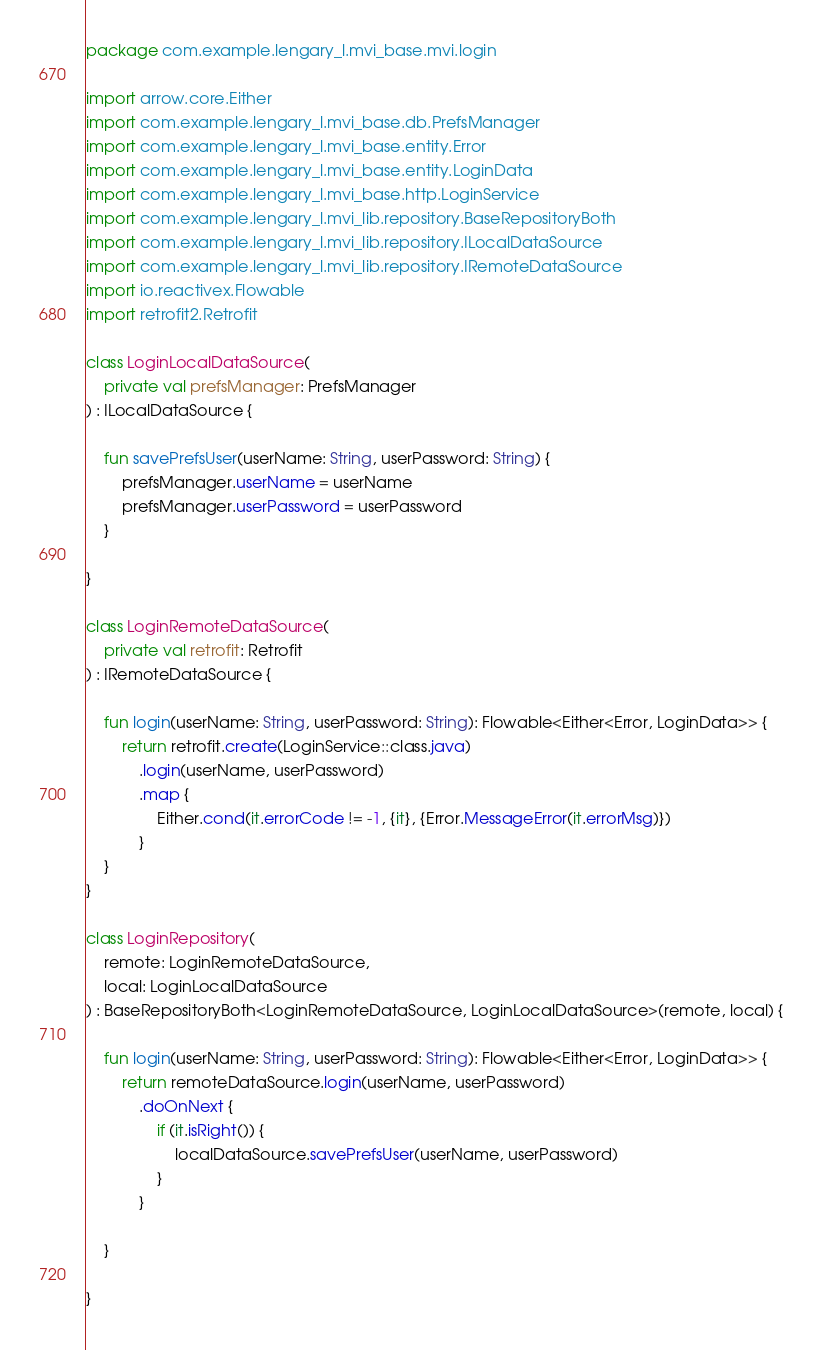Convert code to text. <code><loc_0><loc_0><loc_500><loc_500><_Kotlin_>package com.example.lengary_l.mvi_base.mvi.login

import arrow.core.Either
import com.example.lengary_l.mvi_base.db.PrefsManager
import com.example.lengary_l.mvi_base.entity.Error
import com.example.lengary_l.mvi_base.entity.LoginData
import com.example.lengary_l.mvi_base.http.LoginService
import com.example.lengary_l.mvi_lib.repository.BaseRepositoryBoth
import com.example.lengary_l.mvi_lib.repository.ILocalDataSource
import com.example.lengary_l.mvi_lib.repository.IRemoteDataSource
import io.reactivex.Flowable
import retrofit2.Retrofit

class LoginLocalDataSource(
    private val prefsManager: PrefsManager
) : ILocalDataSource {

    fun savePrefsUser(userName: String, userPassword: String) {
        prefsManager.userName = userName
        prefsManager.userPassword = userPassword
    }

}

class LoginRemoteDataSource(
    private val retrofit: Retrofit
) : IRemoteDataSource {

    fun login(userName: String, userPassword: String): Flowable<Either<Error, LoginData>> {
        return retrofit.create(LoginService::class.java)
            .login(userName, userPassword)
            .map {
                Either.cond(it.errorCode != -1, {it}, {Error.MessageError(it.errorMsg)})
            }
    }
}

class LoginRepository(
    remote: LoginRemoteDataSource,
    local: LoginLocalDataSource
) : BaseRepositoryBoth<LoginRemoteDataSource, LoginLocalDataSource>(remote, local) {

    fun login(userName: String, userPassword: String): Flowable<Either<Error, LoginData>> {
        return remoteDataSource.login(userName, userPassword)
            .doOnNext {
                if (it.isRight()) {
                    localDataSource.savePrefsUser(userName, userPassword)
                }
            }

    }

}
</code> 